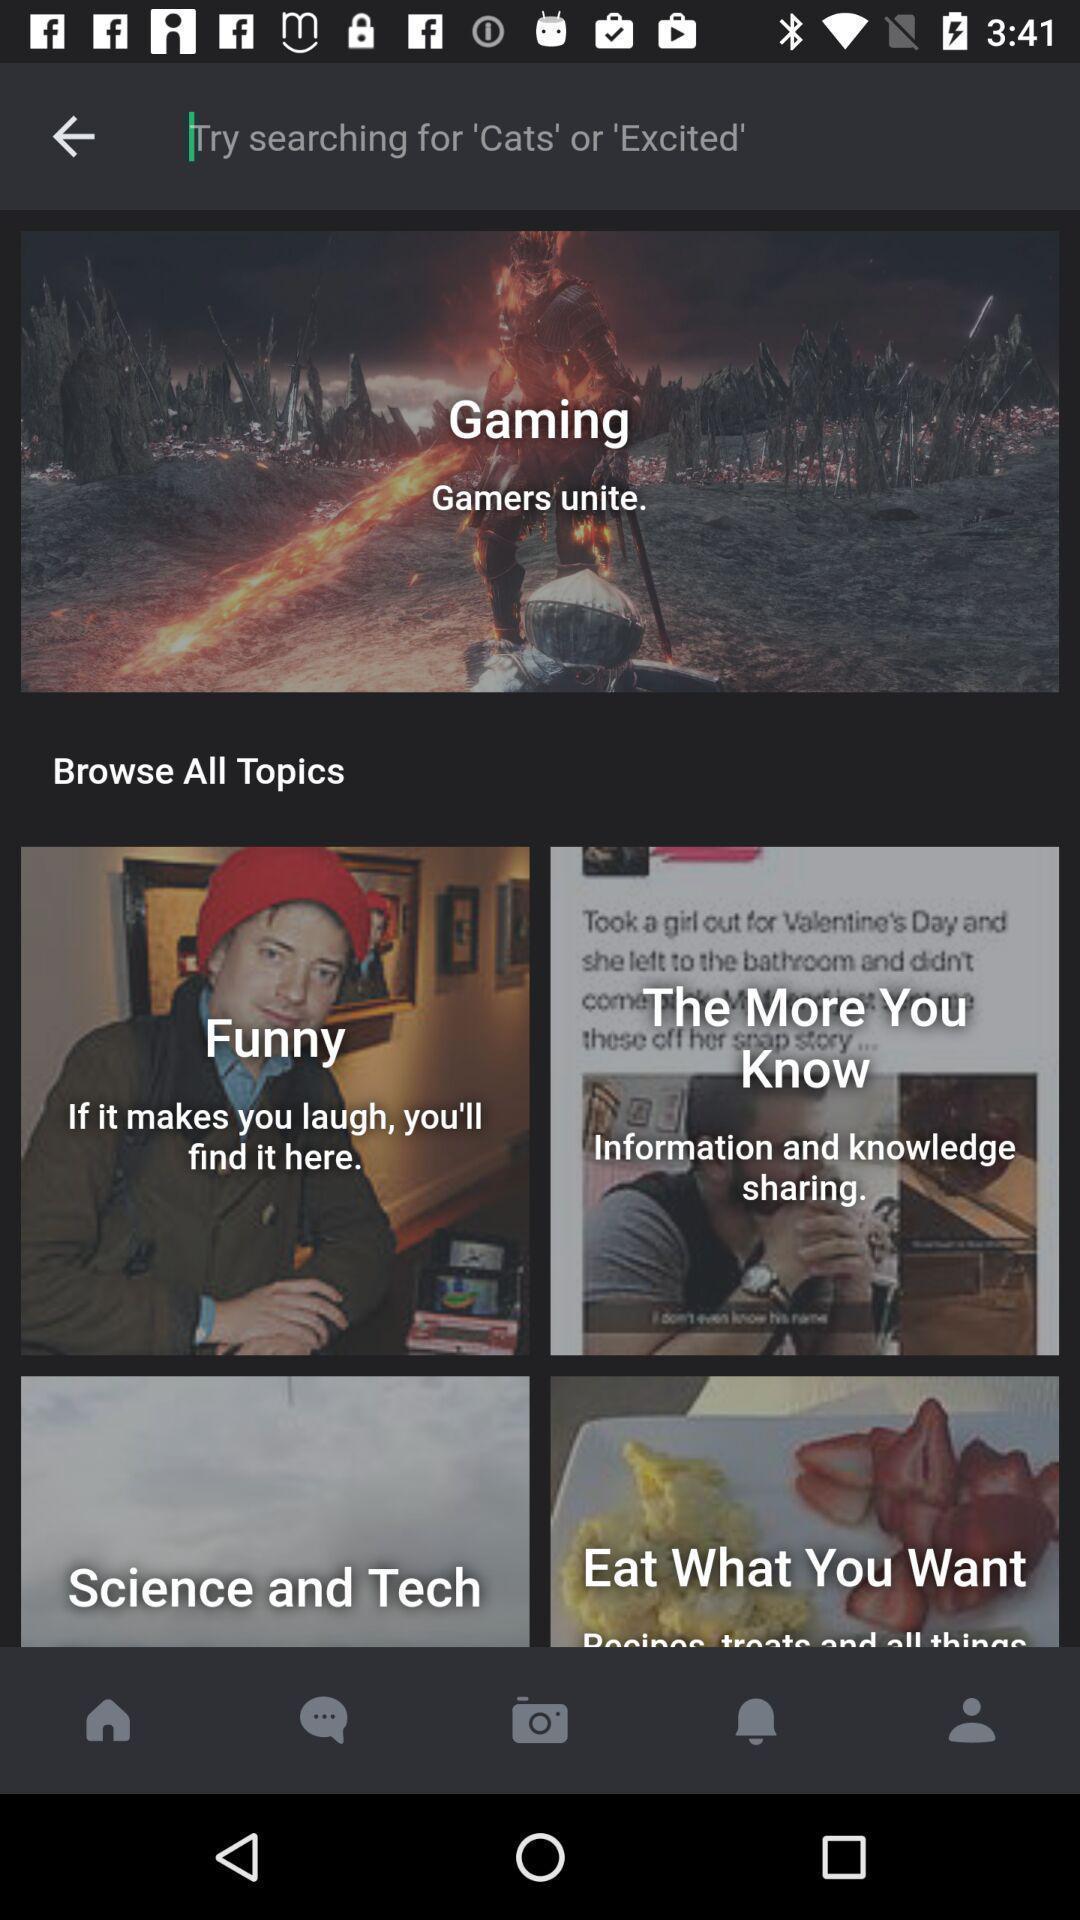Give me a summary of this screen capture. Search page and browse all topics displayed. 